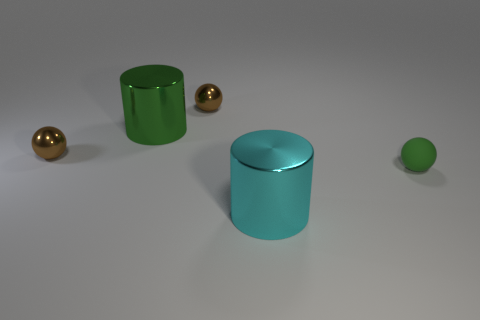How does the size of the smallest sphere compare to the other objects? The smallest sphere in the image is significantly smaller than all the other objects, which include two cylinders and another, larger sphere. The larger objects dominate the composition, with the smallest sphere adding a contrasting element in terms of size. 